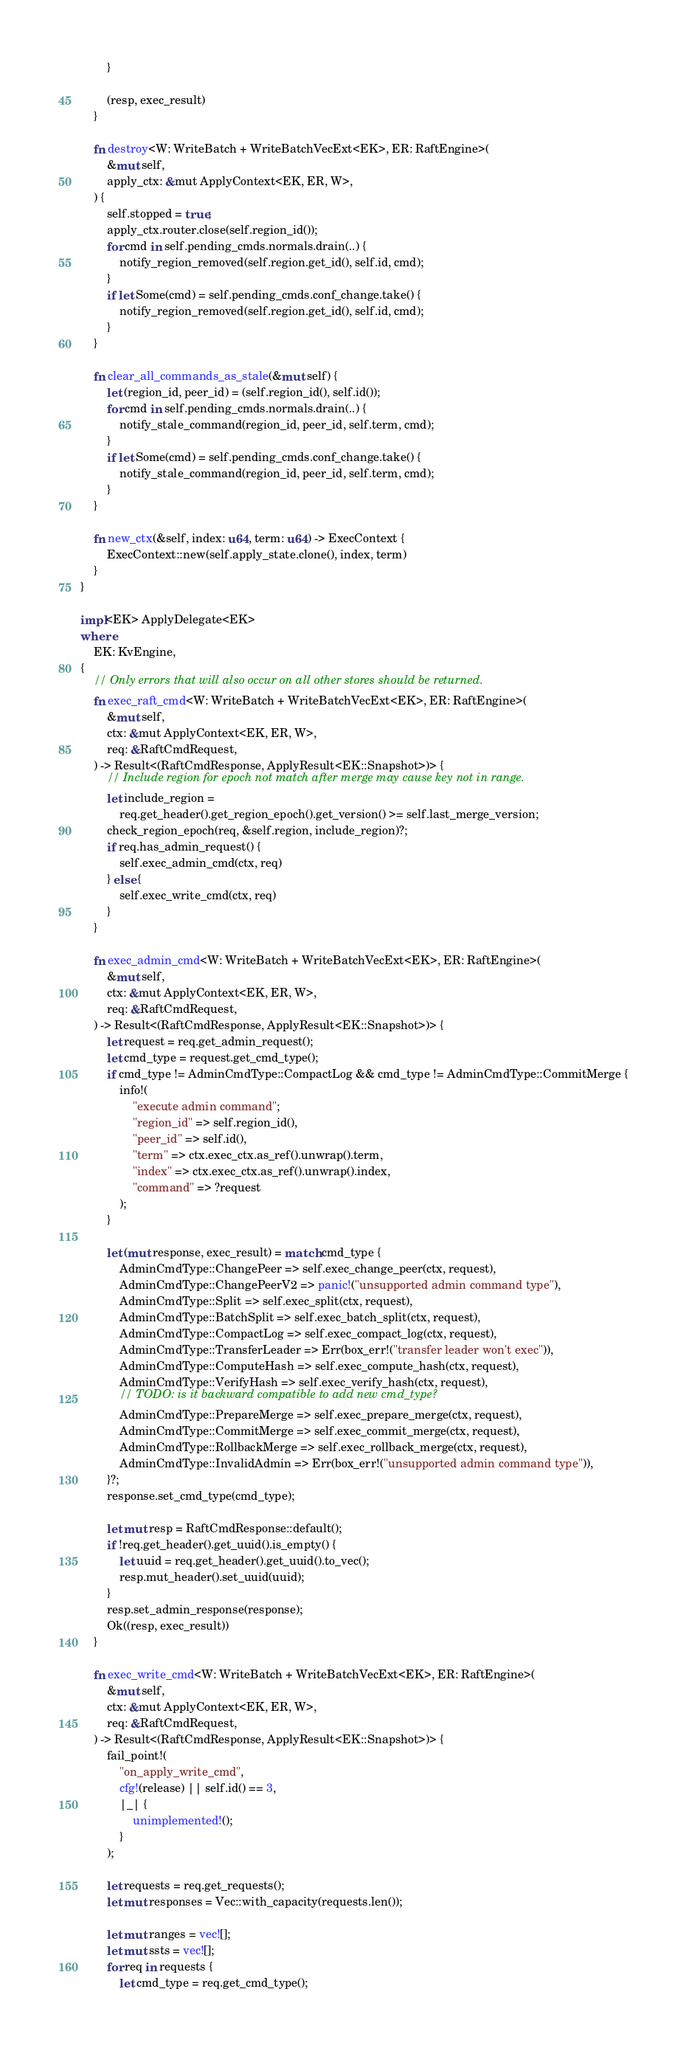<code> <loc_0><loc_0><loc_500><loc_500><_Rust_>        }

        (resp, exec_result)
    }

    fn destroy<W: WriteBatch + WriteBatchVecExt<EK>, ER: RaftEngine>(
        &mut self,
        apply_ctx: &mut ApplyContext<EK, ER, W>,
    ) {
        self.stopped = true;
        apply_ctx.router.close(self.region_id());
        for cmd in self.pending_cmds.normals.drain(..) {
            notify_region_removed(self.region.get_id(), self.id, cmd);
        }
        if let Some(cmd) = self.pending_cmds.conf_change.take() {
            notify_region_removed(self.region.get_id(), self.id, cmd);
        }
    }

    fn clear_all_commands_as_stale(&mut self) {
        let (region_id, peer_id) = (self.region_id(), self.id());
        for cmd in self.pending_cmds.normals.drain(..) {
            notify_stale_command(region_id, peer_id, self.term, cmd);
        }
        if let Some(cmd) = self.pending_cmds.conf_change.take() {
            notify_stale_command(region_id, peer_id, self.term, cmd);
        }
    }

    fn new_ctx(&self, index: u64, term: u64) -> ExecContext {
        ExecContext::new(self.apply_state.clone(), index, term)
    }
}

impl<EK> ApplyDelegate<EK>
where
    EK: KvEngine,
{
    // Only errors that will also occur on all other stores should be returned.
    fn exec_raft_cmd<W: WriteBatch + WriteBatchVecExt<EK>, ER: RaftEngine>(
        &mut self,
        ctx: &mut ApplyContext<EK, ER, W>,
        req: &RaftCmdRequest,
    ) -> Result<(RaftCmdResponse, ApplyResult<EK::Snapshot>)> {
        // Include region for epoch not match after merge may cause key not in range.
        let include_region =
            req.get_header().get_region_epoch().get_version() >= self.last_merge_version;
        check_region_epoch(req, &self.region, include_region)?;
        if req.has_admin_request() {
            self.exec_admin_cmd(ctx, req)
        } else {
            self.exec_write_cmd(ctx, req)
        }
    }

    fn exec_admin_cmd<W: WriteBatch + WriteBatchVecExt<EK>, ER: RaftEngine>(
        &mut self,
        ctx: &mut ApplyContext<EK, ER, W>,
        req: &RaftCmdRequest,
    ) -> Result<(RaftCmdResponse, ApplyResult<EK::Snapshot>)> {
        let request = req.get_admin_request();
        let cmd_type = request.get_cmd_type();
        if cmd_type != AdminCmdType::CompactLog && cmd_type != AdminCmdType::CommitMerge {
            info!(
                "execute admin command";
                "region_id" => self.region_id(),
                "peer_id" => self.id(),
                "term" => ctx.exec_ctx.as_ref().unwrap().term,
                "index" => ctx.exec_ctx.as_ref().unwrap().index,
                "command" => ?request
            );
        }

        let (mut response, exec_result) = match cmd_type {
            AdminCmdType::ChangePeer => self.exec_change_peer(ctx, request),
            AdminCmdType::ChangePeerV2 => panic!("unsupported admin command type"),
            AdminCmdType::Split => self.exec_split(ctx, request),
            AdminCmdType::BatchSplit => self.exec_batch_split(ctx, request),
            AdminCmdType::CompactLog => self.exec_compact_log(ctx, request),
            AdminCmdType::TransferLeader => Err(box_err!("transfer leader won't exec")),
            AdminCmdType::ComputeHash => self.exec_compute_hash(ctx, request),
            AdminCmdType::VerifyHash => self.exec_verify_hash(ctx, request),
            // TODO: is it backward compatible to add new cmd_type?
            AdminCmdType::PrepareMerge => self.exec_prepare_merge(ctx, request),
            AdminCmdType::CommitMerge => self.exec_commit_merge(ctx, request),
            AdminCmdType::RollbackMerge => self.exec_rollback_merge(ctx, request),
            AdminCmdType::InvalidAdmin => Err(box_err!("unsupported admin command type")),
        }?;
        response.set_cmd_type(cmd_type);

        let mut resp = RaftCmdResponse::default();
        if !req.get_header().get_uuid().is_empty() {
            let uuid = req.get_header().get_uuid().to_vec();
            resp.mut_header().set_uuid(uuid);
        }
        resp.set_admin_response(response);
        Ok((resp, exec_result))
    }

    fn exec_write_cmd<W: WriteBatch + WriteBatchVecExt<EK>, ER: RaftEngine>(
        &mut self,
        ctx: &mut ApplyContext<EK, ER, W>,
        req: &RaftCmdRequest,
    ) -> Result<(RaftCmdResponse, ApplyResult<EK::Snapshot>)> {
        fail_point!(
            "on_apply_write_cmd",
            cfg!(release) || self.id() == 3,
            |_| {
                unimplemented!();
            }
        );

        let requests = req.get_requests();
        let mut responses = Vec::with_capacity(requests.len());

        let mut ranges = vec![];
        let mut ssts = vec![];
        for req in requests {
            let cmd_type = req.get_cmd_type();</code> 